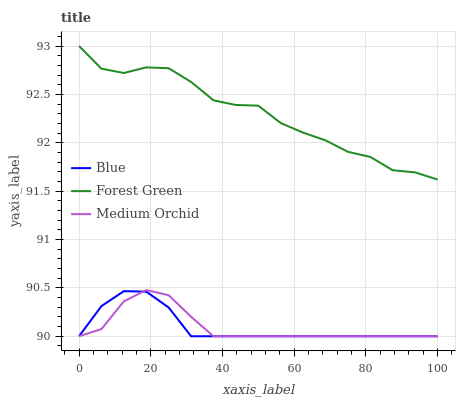Does Blue have the minimum area under the curve?
Answer yes or no. Yes. Does Forest Green have the maximum area under the curve?
Answer yes or no. Yes. Does Medium Orchid have the minimum area under the curve?
Answer yes or no. No. Does Medium Orchid have the maximum area under the curve?
Answer yes or no. No. Is Blue the smoothest?
Answer yes or no. Yes. Is Forest Green the roughest?
Answer yes or no. Yes. Is Medium Orchid the smoothest?
Answer yes or no. No. Is Medium Orchid the roughest?
Answer yes or no. No. Does Blue have the lowest value?
Answer yes or no. Yes. Does Forest Green have the lowest value?
Answer yes or no. No. Does Forest Green have the highest value?
Answer yes or no. Yes. Does Medium Orchid have the highest value?
Answer yes or no. No. Is Medium Orchid less than Forest Green?
Answer yes or no. Yes. Is Forest Green greater than Medium Orchid?
Answer yes or no. Yes. Does Blue intersect Medium Orchid?
Answer yes or no. Yes. Is Blue less than Medium Orchid?
Answer yes or no. No. Is Blue greater than Medium Orchid?
Answer yes or no. No. Does Medium Orchid intersect Forest Green?
Answer yes or no. No. 